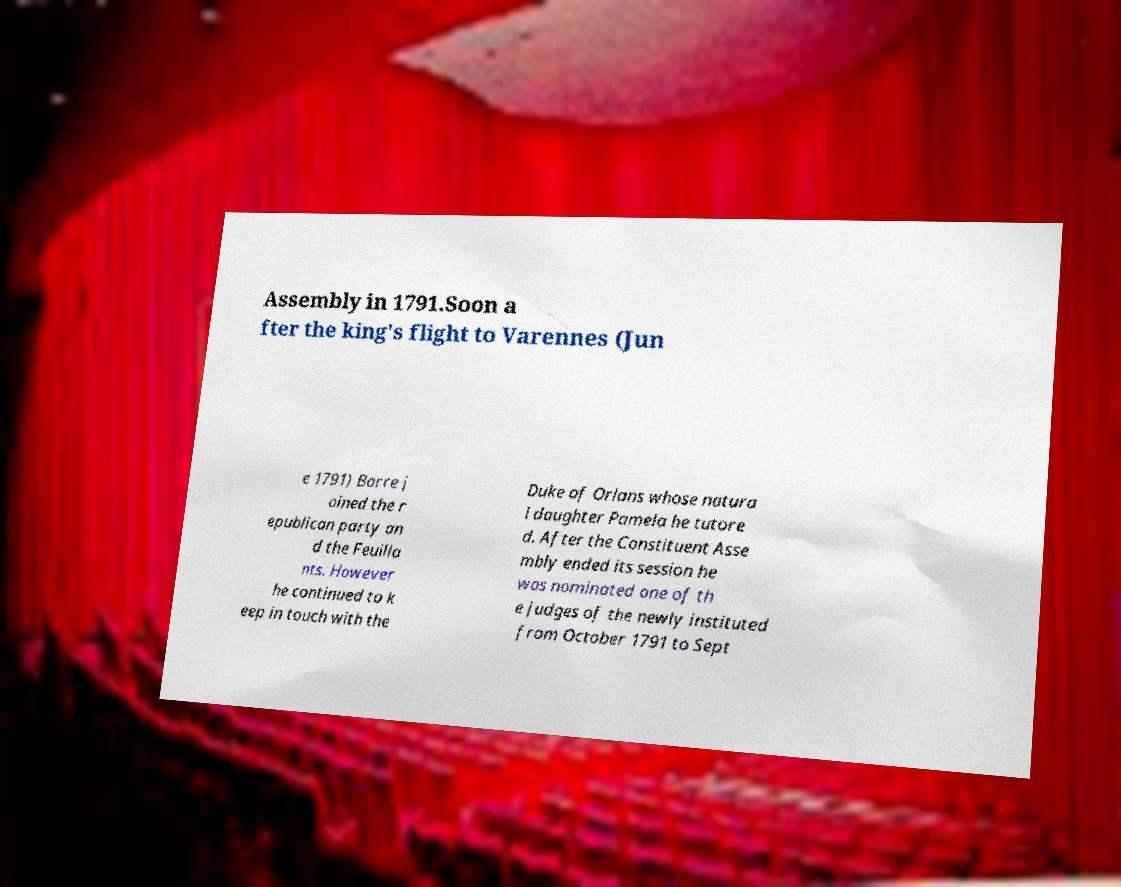Could you assist in decoding the text presented in this image and type it out clearly? Assembly in 1791.Soon a fter the king's flight to Varennes (Jun e 1791) Barre j oined the r epublican party an d the Feuilla nts. However he continued to k eep in touch with the Duke of Orlans whose natura l daughter Pamela he tutore d. After the Constituent Asse mbly ended its session he was nominated one of th e judges of the newly instituted from October 1791 to Sept 